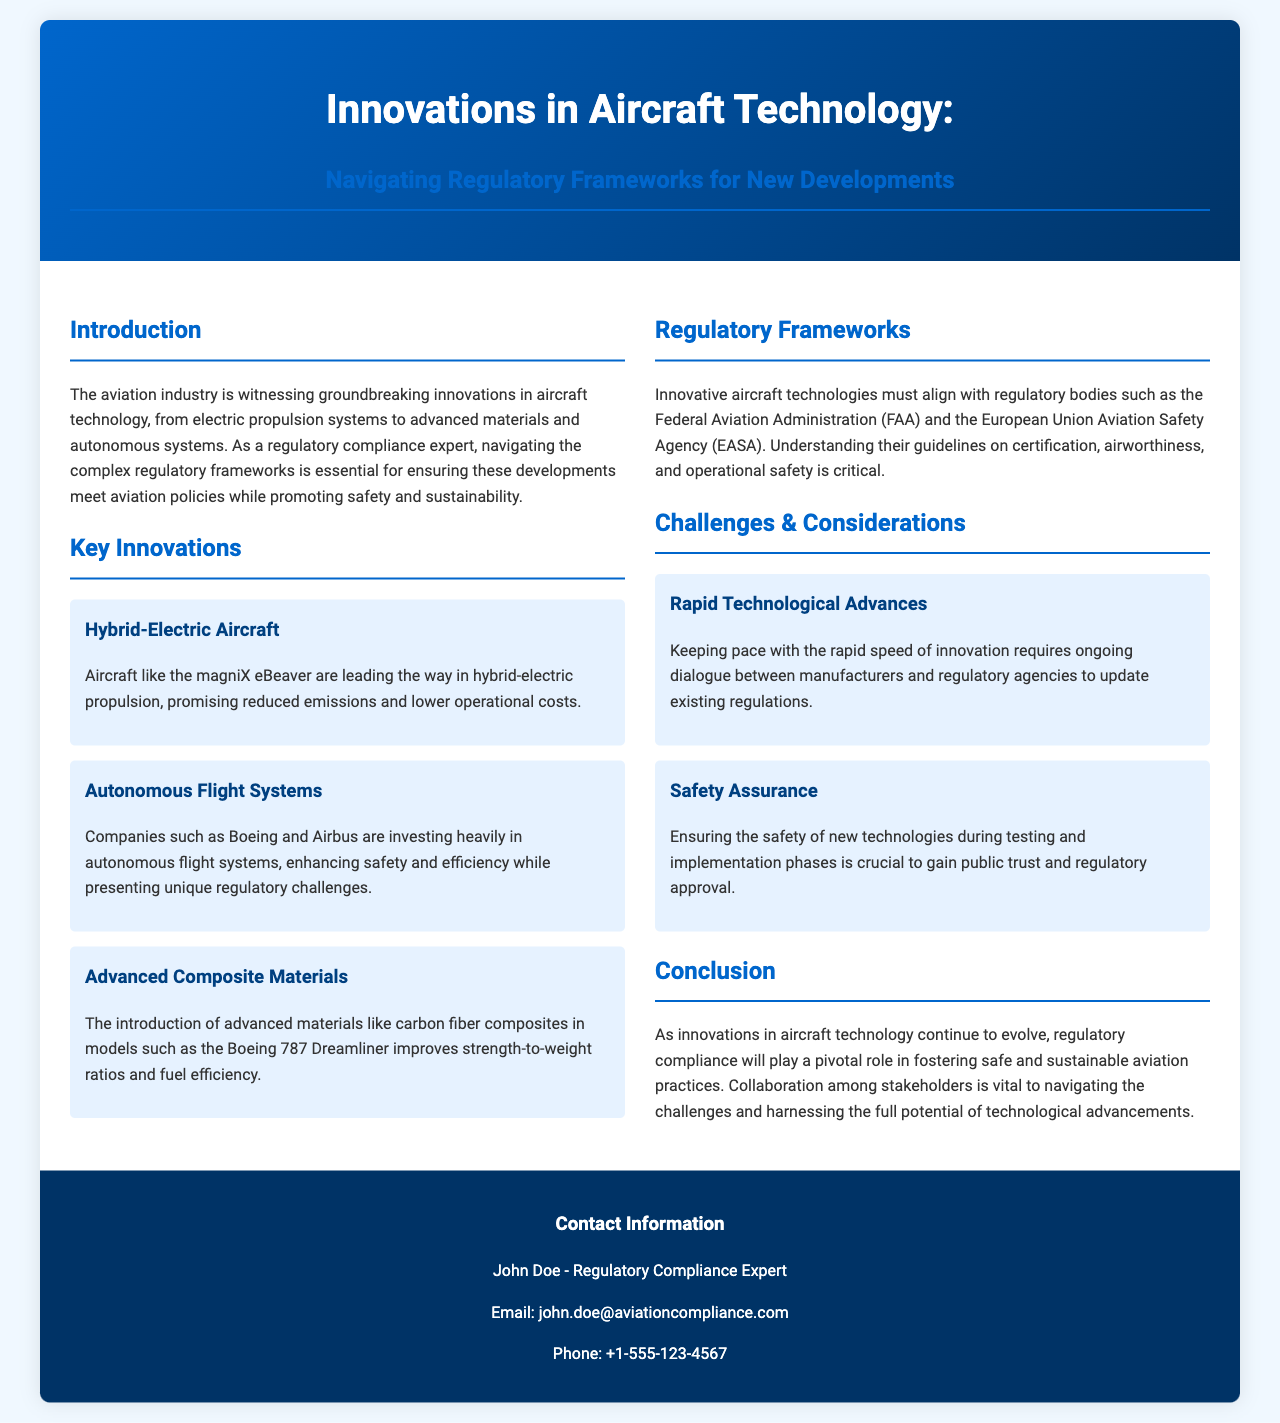what is the title of the brochure? The title of the brochure is displayed prominently at the top, summarizing the main topic.
Answer: Innovations in Aircraft Technology: Navigating Regulatory Frameworks for New Developments who is the regulatory compliance expert mentioned in the brochure? The contact information section provides the name of the regulatory compliance expert associated with the document.
Answer: John Doe which aircraft is mentioned as a leader in hybrid-electric propulsion? The brochure lists specific aircraft that represent advancements in hybrid-electric technology.
Answer: magniX eBeaver what are the two regulatory bodies mentioned in relation to aircraft innovations? The document specifies key regulatory agencies that govern aircraft safety and compliance.
Answer: FAA and EASA what challenge is associated with rapid technological advances? The brochure outlines specific challenges faced due to the pace of innovation in aircraft technology.
Answer: Ongoing dialogue between manufacturers and regulatory agencies which advanced material is noted for improving fuel efficiency? The content highlights innovative materials that offer benefits in aircraft design and efficiency.
Answer: Carbon fiber composites what is the crucial focus during the testing and implementation phases of new technologies? The brochure states an important consideration that must be emphasized during the development of new technologies.
Answer: Safety assurance how can collaboration among stakeholders be characterized according to the document? The conclusion of the brochure emphasizes the need for cooperation in several critical areas.
Answer: Vital to navigating challenges what type of propulsion system is part of the key innovations section? The brochure categorizes several innovations and specifies a type of propulsion system in the aviation industry.
Answer: Hybrid-electric propulsion 